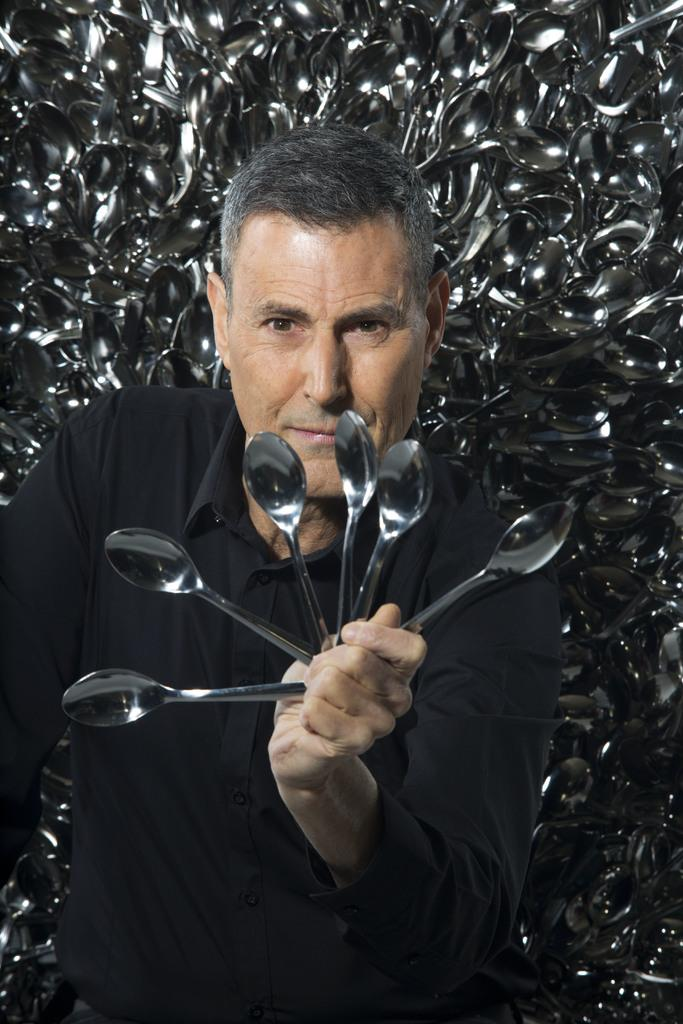What is the main subject of the image? There is a man in the image. What is the man holding in the image? The man is holding spoons. What type of territory does the man claim to own in the image? There is no indication in the image that the man is claiming ownership of any territory. 